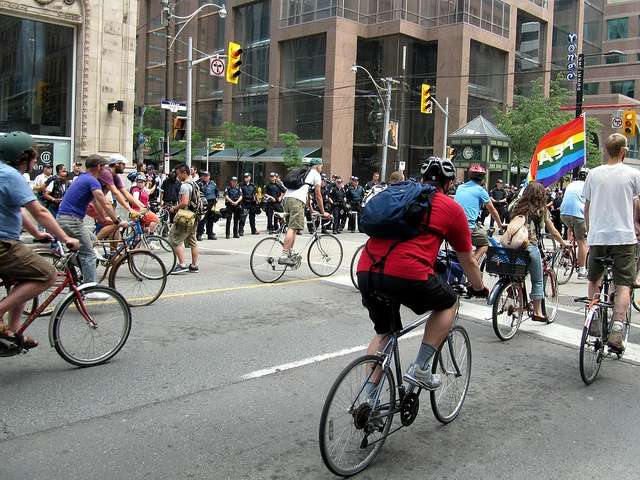Describe the objects in this image and their specific colors. I can see people in gray, black, brown, and maroon tones, bicycle in gray, black, and darkgray tones, bicycle in gray, darkgray, black, and maroon tones, people in gray, black, and maroon tones, and backpack in gray, black, navy, and blue tones in this image. 